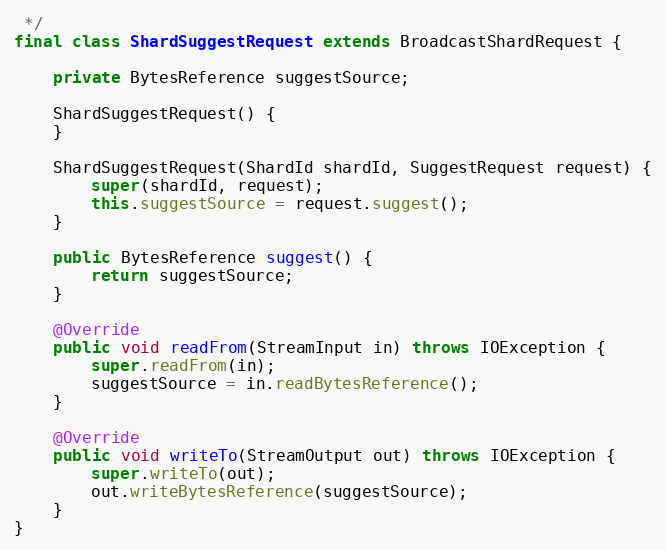Convert code to text. <code><loc_0><loc_0><loc_500><loc_500><_Java_> */
final class ShardSuggestRequest extends BroadcastShardRequest {

    private BytesReference suggestSource;

    ShardSuggestRequest() {
    }

    ShardSuggestRequest(ShardId shardId, SuggestRequest request) {
        super(shardId, request);
        this.suggestSource = request.suggest();
    }

    public BytesReference suggest() {
        return suggestSource;
    }

    @Override
    public void readFrom(StreamInput in) throws IOException {
        super.readFrom(in);
        suggestSource = in.readBytesReference();
    }

    @Override
    public void writeTo(StreamOutput out) throws IOException {
        super.writeTo(out);
        out.writeBytesReference(suggestSource);
    }
}
</code> 